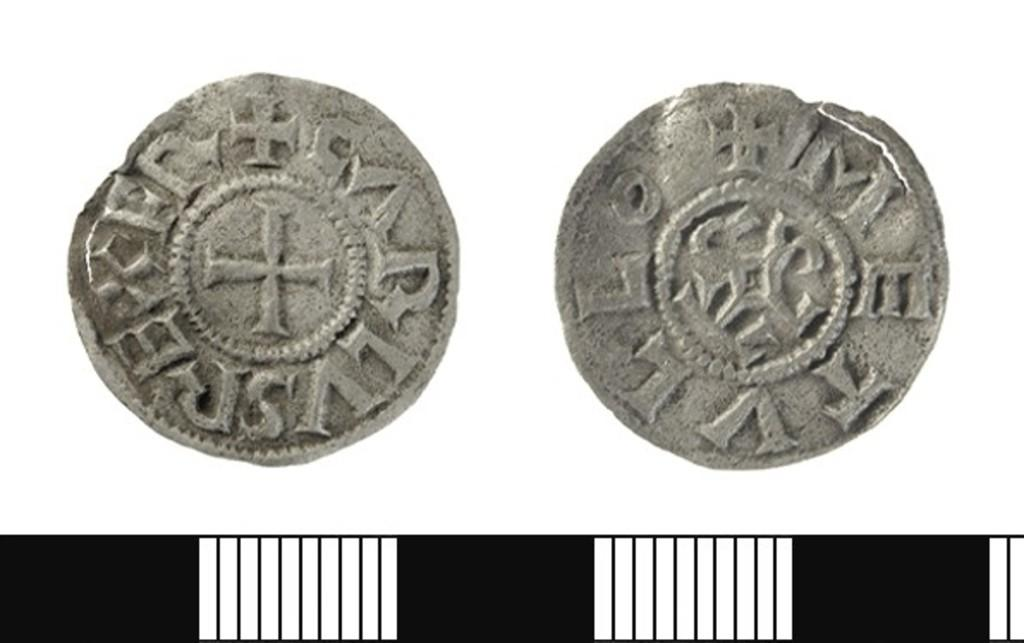<image>
Describe the image concisely. A misshapen silver colored coin with the letters METVLL on one side and LVSREXFN on the other. 